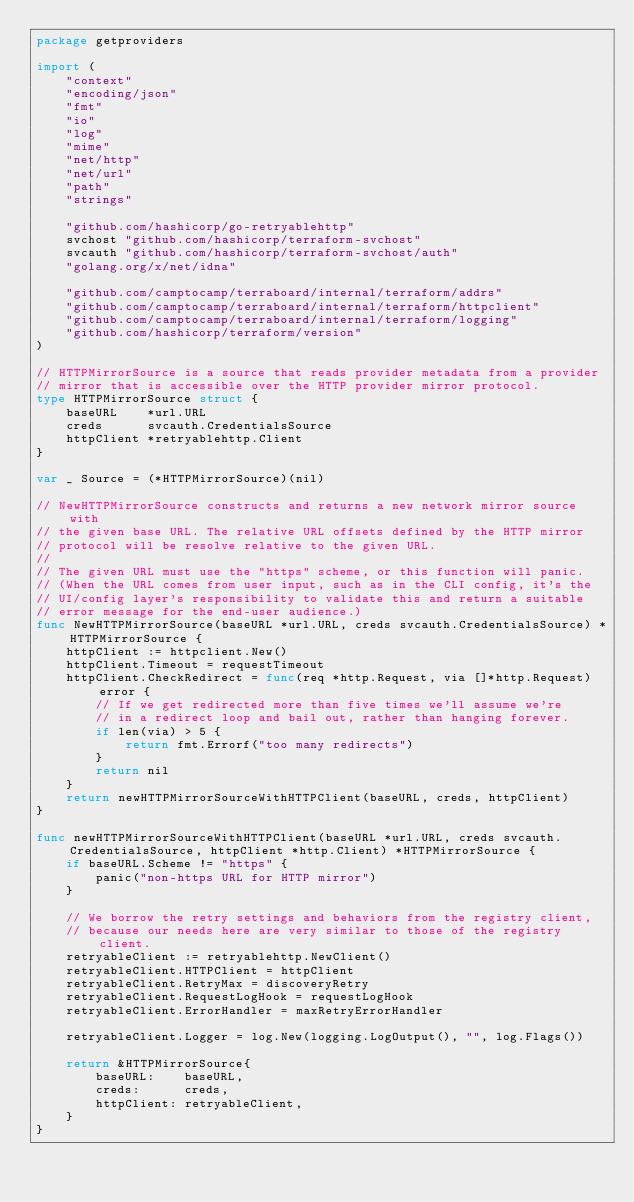<code> <loc_0><loc_0><loc_500><loc_500><_Go_>package getproviders

import (
	"context"
	"encoding/json"
	"fmt"
	"io"
	"log"
	"mime"
	"net/http"
	"net/url"
	"path"
	"strings"

	"github.com/hashicorp/go-retryablehttp"
	svchost "github.com/hashicorp/terraform-svchost"
	svcauth "github.com/hashicorp/terraform-svchost/auth"
	"golang.org/x/net/idna"

	"github.com/camptocamp/terraboard/internal/terraform/addrs"
	"github.com/camptocamp/terraboard/internal/terraform/httpclient"
	"github.com/camptocamp/terraboard/internal/terraform/logging"
	"github.com/hashicorp/terraform/version"
)

// HTTPMirrorSource is a source that reads provider metadata from a provider
// mirror that is accessible over the HTTP provider mirror protocol.
type HTTPMirrorSource struct {
	baseURL    *url.URL
	creds      svcauth.CredentialsSource
	httpClient *retryablehttp.Client
}

var _ Source = (*HTTPMirrorSource)(nil)

// NewHTTPMirrorSource constructs and returns a new network mirror source with
// the given base URL. The relative URL offsets defined by the HTTP mirror
// protocol will be resolve relative to the given URL.
//
// The given URL must use the "https" scheme, or this function will panic.
// (When the URL comes from user input, such as in the CLI config, it's the
// UI/config layer's responsibility to validate this and return a suitable
// error message for the end-user audience.)
func NewHTTPMirrorSource(baseURL *url.URL, creds svcauth.CredentialsSource) *HTTPMirrorSource {
	httpClient := httpclient.New()
	httpClient.Timeout = requestTimeout
	httpClient.CheckRedirect = func(req *http.Request, via []*http.Request) error {
		// If we get redirected more than five times we'll assume we're
		// in a redirect loop and bail out, rather than hanging forever.
		if len(via) > 5 {
			return fmt.Errorf("too many redirects")
		}
		return nil
	}
	return newHTTPMirrorSourceWithHTTPClient(baseURL, creds, httpClient)
}

func newHTTPMirrorSourceWithHTTPClient(baseURL *url.URL, creds svcauth.CredentialsSource, httpClient *http.Client) *HTTPMirrorSource {
	if baseURL.Scheme != "https" {
		panic("non-https URL for HTTP mirror")
	}

	// We borrow the retry settings and behaviors from the registry client,
	// because our needs here are very similar to those of the registry client.
	retryableClient := retryablehttp.NewClient()
	retryableClient.HTTPClient = httpClient
	retryableClient.RetryMax = discoveryRetry
	retryableClient.RequestLogHook = requestLogHook
	retryableClient.ErrorHandler = maxRetryErrorHandler

	retryableClient.Logger = log.New(logging.LogOutput(), "", log.Flags())

	return &HTTPMirrorSource{
		baseURL:    baseURL,
		creds:      creds,
		httpClient: retryableClient,
	}
}
</code> 